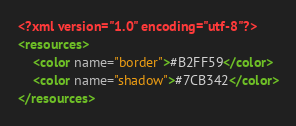<code> <loc_0><loc_0><loc_500><loc_500><_XML_><?xml version="1.0" encoding="utf-8"?>
<resources>
    <color name="border">#B2FF59</color>
    <color name="shadow">#7CB342</color>
</resources></code> 